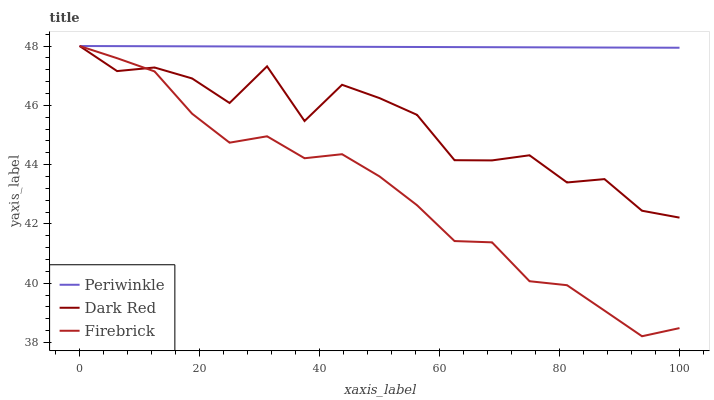Does Firebrick have the minimum area under the curve?
Answer yes or no. Yes. Does Periwinkle have the maximum area under the curve?
Answer yes or no. Yes. Does Periwinkle have the minimum area under the curve?
Answer yes or no. No. Does Firebrick have the maximum area under the curve?
Answer yes or no. No. Is Periwinkle the smoothest?
Answer yes or no. Yes. Is Dark Red the roughest?
Answer yes or no. Yes. Is Firebrick the smoothest?
Answer yes or no. No. Is Firebrick the roughest?
Answer yes or no. No. Does Firebrick have the lowest value?
Answer yes or no. Yes. Does Periwinkle have the lowest value?
Answer yes or no. No. Does Periwinkle have the highest value?
Answer yes or no. Yes. Does Firebrick intersect Dark Red?
Answer yes or no. Yes. Is Firebrick less than Dark Red?
Answer yes or no. No. Is Firebrick greater than Dark Red?
Answer yes or no. No. 